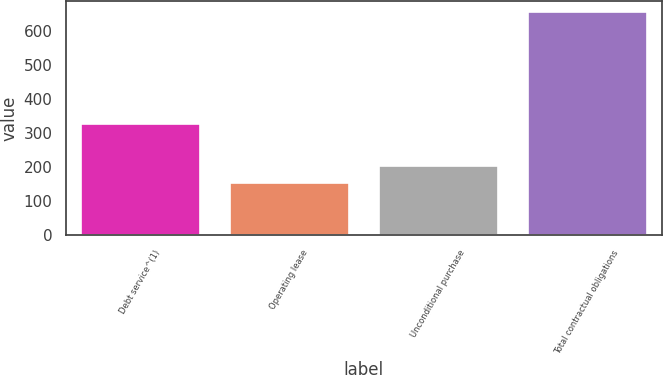Convert chart. <chart><loc_0><loc_0><loc_500><loc_500><bar_chart><fcel>Debt service^(1)<fcel>Operating lease<fcel>Unconditional purchase<fcel>Total contractual obligations<nl><fcel>327.9<fcel>154.8<fcel>204.9<fcel>655.8<nl></chart> 